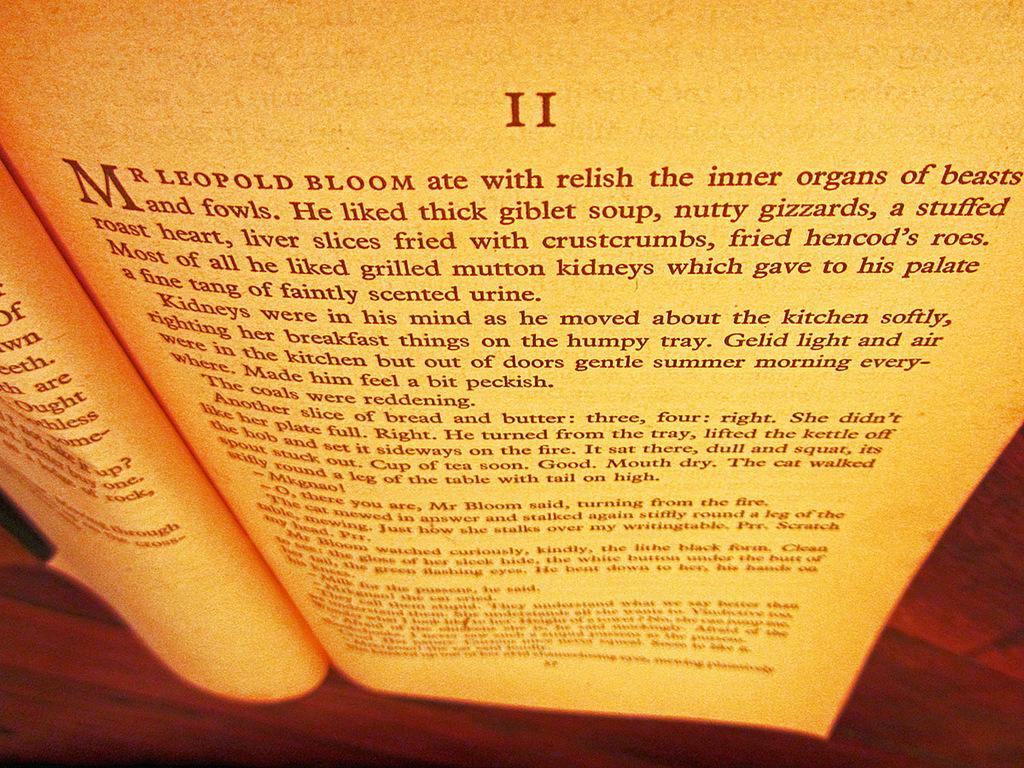What is the first name on the page?
Ensure brevity in your answer.  Mr. leopold bloom. 